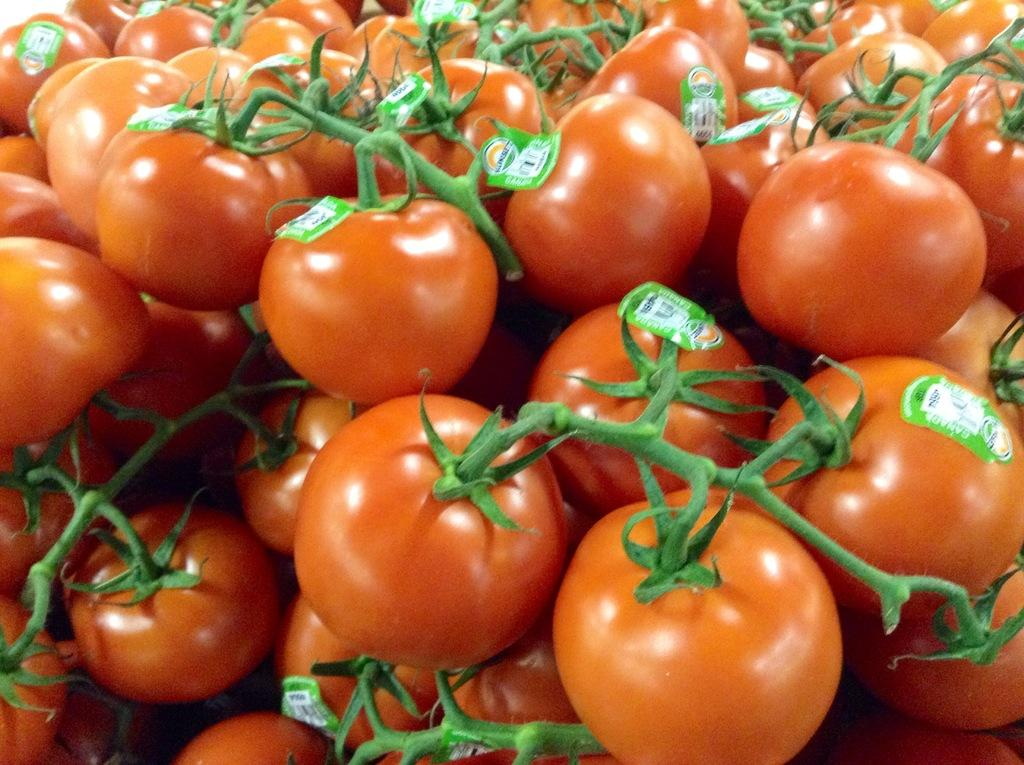What type of fruit can be seen in the image? There are tomatoes in the image. Are there any additional features on the tomatoes? Yes, there are stickers on the tomatoes. What type of bed can be seen in the image? There is no bed present in the image; it only features tomatoes with stickers. 